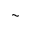Convert formula to latex. <formula><loc_0><loc_0><loc_500><loc_500>\sim</formula> 